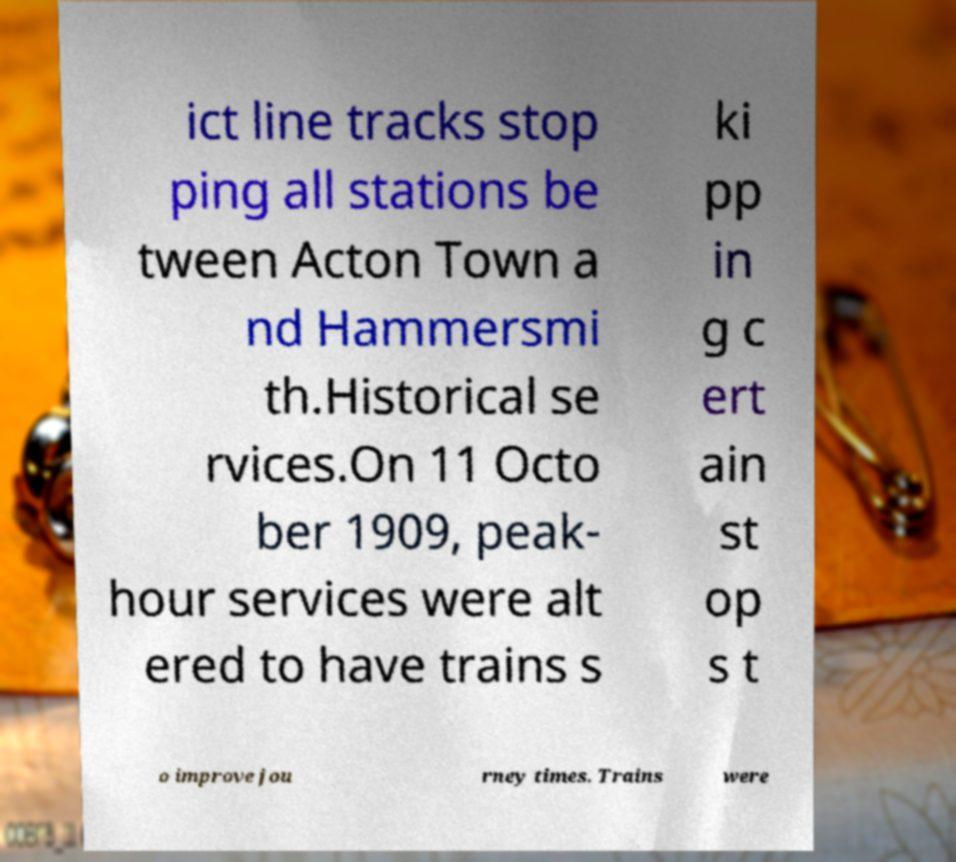Could you assist in decoding the text presented in this image and type it out clearly? ict line tracks stop ping all stations be tween Acton Town a nd Hammersmi th.Historical se rvices.On 11 Octo ber 1909, peak- hour services were alt ered to have trains s ki pp in g c ert ain st op s t o improve jou rney times. Trains were 